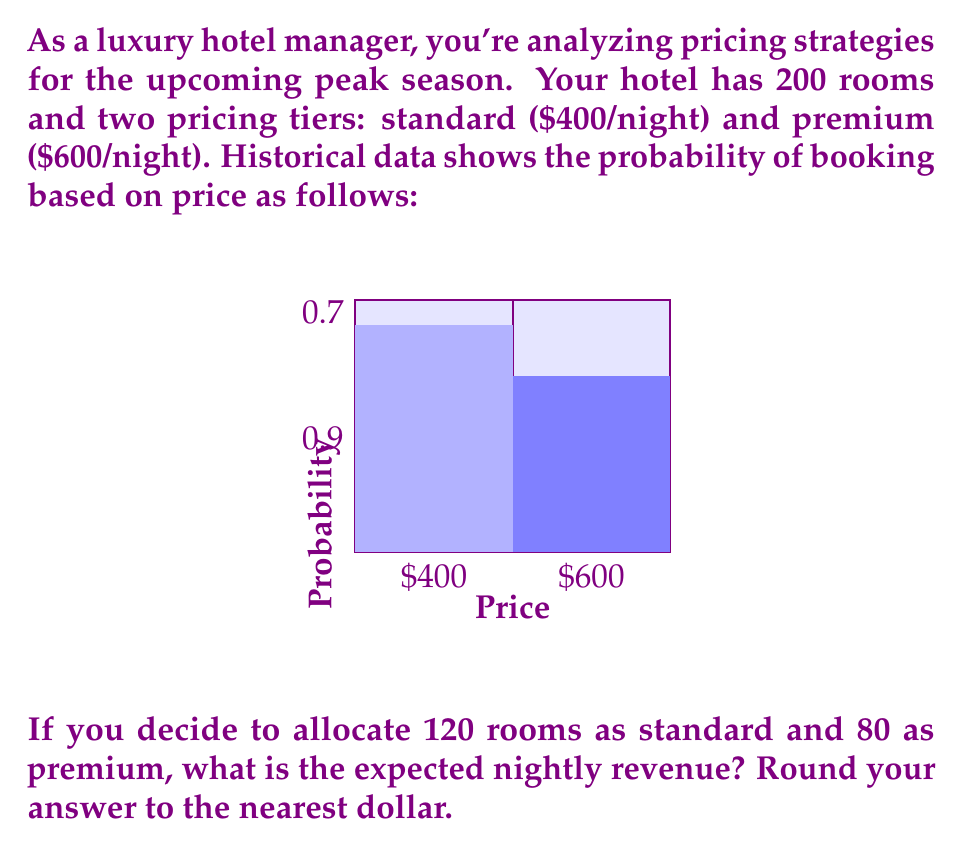Can you solve this math problem? Let's approach this step-by-step:

1) First, let's calculate the expected revenue for standard rooms:
   - Number of standard rooms: 120
   - Price per standard room: $400
   - Probability of booking a standard room: 0.9
   - Expected revenue from standard rooms: 
     $$120 \times $400 \times 0.9 = $43,200$$

2) Now, let's calculate the expected revenue for premium rooms:
   - Number of premium rooms: 80
   - Price per premium room: $600
   - Probability of booking a premium room: 0.7
   - Expected revenue from premium rooms:
     $$80 \times $600 \times 0.7 = $33,600$$

3) The total expected nightly revenue is the sum of the expected revenues from standard and premium rooms:
   $$\text{Total Expected Revenue} = $43,200 + $33,600 = $76,800$$

4) Rounding to the nearest dollar doesn't change the result in this case.

Therefore, the expected nightly revenue is $76,800.
Answer: $76,800 